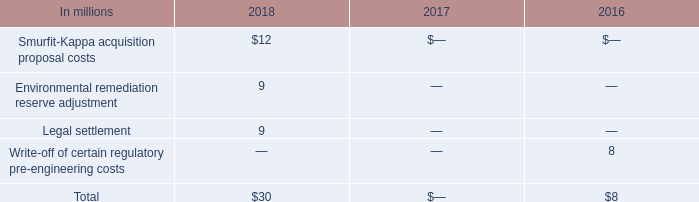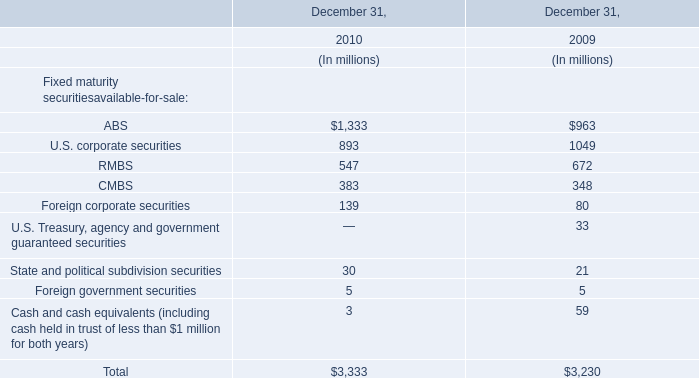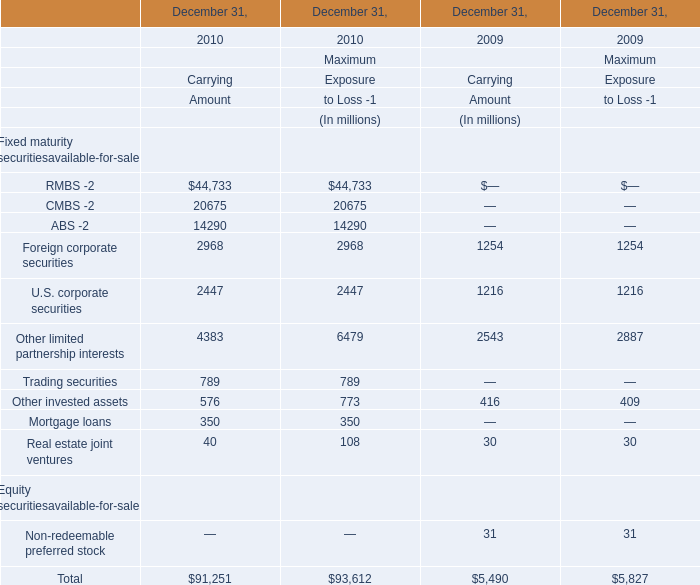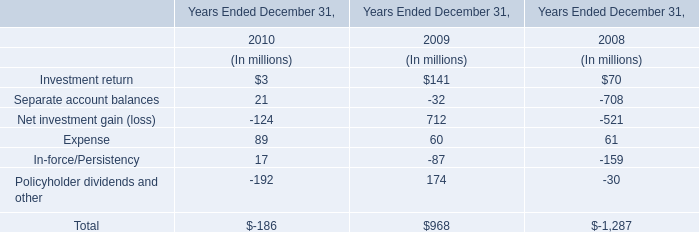What's the total value of all Carrying Amount that are smaller than 400 in 2010 for Fixed maturity securitiesavailable-for-sale? (in million) 
Computations: (40 + 350)
Answer: 390.0. 